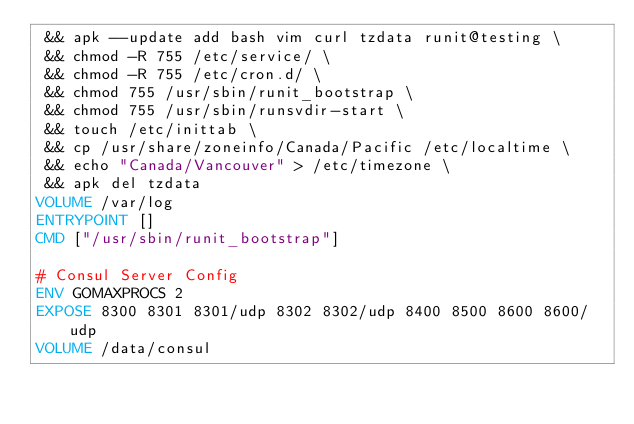Convert code to text. <code><loc_0><loc_0><loc_500><loc_500><_Dockerfile_> && apk --update add bash vim curl tzdata runit@testing \
 && chmod -R 755 /etc/service/ \
 && chmod -R 755 /etc/cron.d/ \
 && chmod 755 /usr/sbin/runit_bootstrap \
 && chmod 755 /usr/sbin/runsvdir-start \
 && touch /etc/inittab \
 && cp /usr/share/zoneinfo/Canada/Pacific /etc/localtime \
 && echo "Canada/Vancouver" > /etc/timezone \
 && apk del tzdata
VOLUME /var/log
ENTRYPOINT []
CMD ["/usr/sbin/runit_bootstrap"]

# Consul Server Config
ENV GOMAXPROCS 2
EXPOSE 8300 8301 8301/udp 8302 8302/udp 8400 8500 8600 8600/udp
VOLUME /data/consul
</code> 